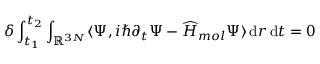Convert formula to latex. <formula><loc_0><loc_0><loc_500><loc_500>\delta \int _ { t _ { 1 } } ^ { t _ { 2 } } \int _ { { \mathbb { R } } ^ { 3 N } } \langle \Psi , i \hbar { \partial } _ { t } \Psi - \widehat { H } _ { m o l } \Psi \rangle \, d r \, { d t = 0 }</formula> 